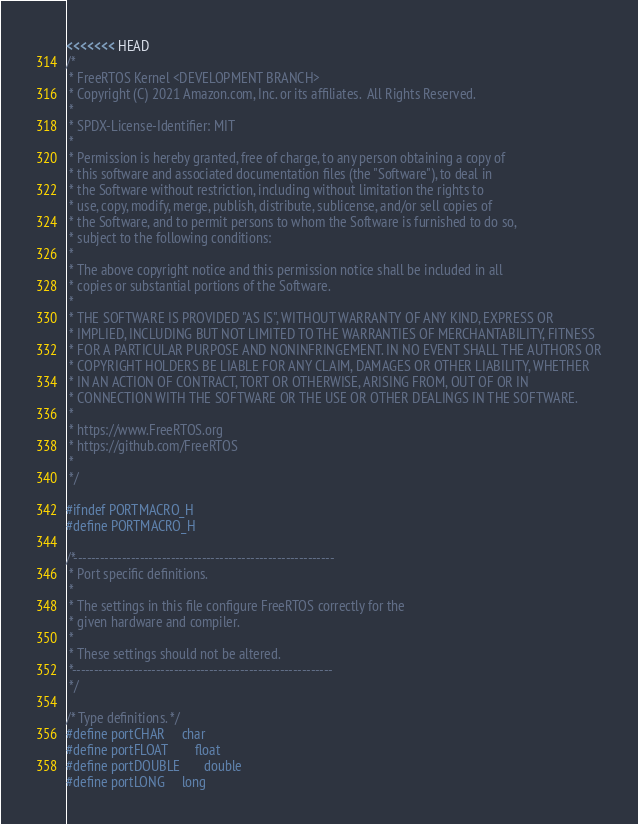<code> <loc_0><loc_0><loc_500><loc_500><_C_><<<<<<< HEAD
/*
 * FreeRTOS Kernel <DEVELOPMENT BRANCH>
 * Copyright (C) 2021 Amazon.com, Inc. or its affiliates.  All Rights Reserved.
 *
 * SPDX-License-Identifier: MIT
 *
 * Permission is hereby granted, free of charge, to any person obtaining a copy of
 * this software and associated documentation files (the "Software"), to deal in
 * the Software without restriction, including without limitation the rights to
 * use, copy, modify, merge, publish, distribute, sublicense, and/or sell copies of
 * the Software, and to permit persons to whom the Software is furnished to do so,
 * subject to the following conditions:
 *
 * The above copyright notice and this permission notice shall be included in all
 * copies or substantial portions of the Software.
 *
 * THE SOFTWARE IS PROVIDED "AS IS", WITHOUT WARRANTY OF ANY KIND, EXPRESS OR
 * IMPLIED, INCLUDING BUT NOT LIMITED TO THE WARRANTIES OF MERCHANTABILITY, FITNESS
 * FOR A PARTICULAR PURPOSE AND NONINFRINGEMENT. IN NO EVENT SHALL THE AUTHORS OR
 * COPYRIGHT HOLDERS BE LIABLE FOR ANY CLAIM, DAMAGES OR OTHER LIABILITY, WHETHER
 * IN AN ACTION OF CONTRACT, TORT OR OTHERWISE, ARISING FROM, OUT OF OR IN
 * CONNECTION WITH THE SOFTWARE OR THE USE OR OTHER DEALINGS IN THE SOFTWARE.
 *
 * https://www.FreeRTOS.org
 * https://github.com/FreeRTOS
 *
 */

#ifndef PORTMACRO_H
#define PORTMACRO_H

/*-----------------------------------------------------------
 * Port specific definitions.
 *
 * The settings in this file configure FreeRTOS correctly for the
 * given hardware and compiler.
 *
 * These settings should not be altered.
 *-----------------------------------------------------------
 */

/* Type definitions. */
#define portCHAR		char
#define portFLOAT		float
#define portDOUBLE		double
#define portLONG		long</code> 